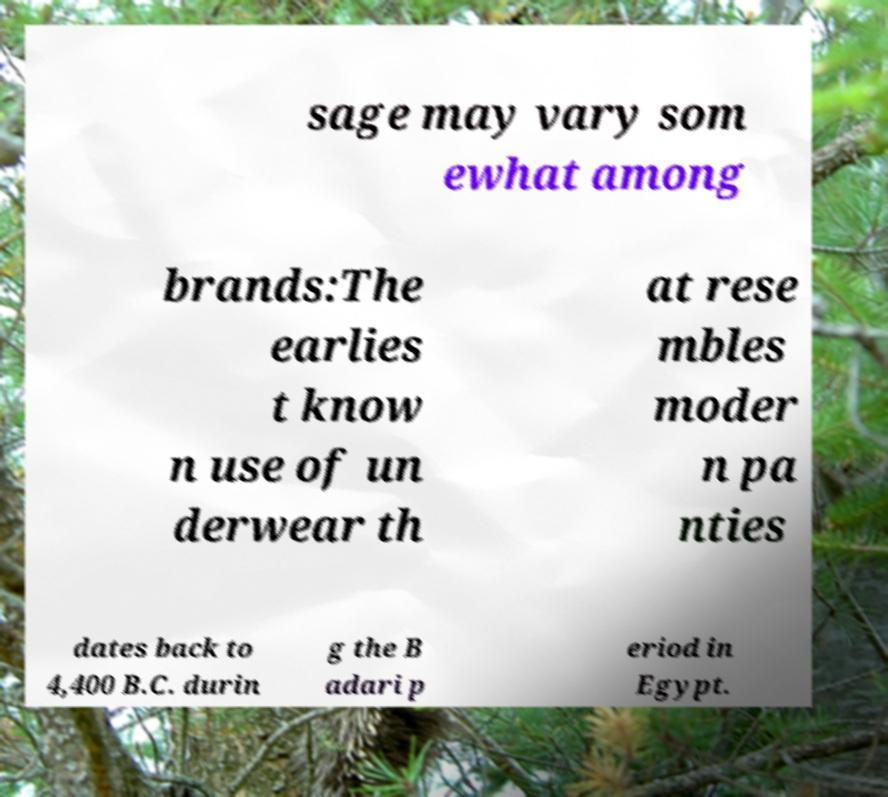Could you extract and type out the text from this image? sage may vary som ewhat among brands:The earlies t know n use of un derwear th at rese mbles moder n pa nties dates back to 4,400 B.C. durin g the B adari p eriod in Egypt. 